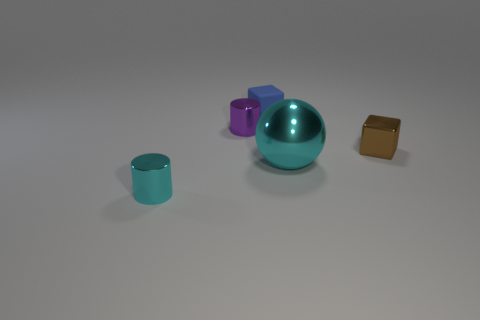There is a tiny metallic object that is behind the brown metal object; how many small brown objects are behind it?
Give a very brief answer. 0. There is a cyan cylinder that is the same size as the blue matte cube; what material is it?
Give a very brief answer. Metal. What number of other objects are the same material as the tiny cyan cylinder?
Your response must be concise. 3. How many blocks are on the left side of the brown metal object?
Provide a succinct answer. 1. How many blocks are small blue matte things or tiny purple objects?
Offer a terse response. 1. There is a object that is both to the left of the small blue block and in front of the tiny purple cylinder; what size is it?
Ensure brevity in your answer.  Small. What number of other things are the same color as the big metal object?
Keep it short and to the point. 1. Do the blue thing and the tiny cube that is on the right side of the cyan sphere have the same material?
Make the answer very short. No. What number of things are either small blue blocks behind the big ball or big cyan shiny things?
Offer a very short reply. 2. The object that is behind the large shiny thing and right of the blue matte thing has what shape?
Provide a short and direct response. Cube. 